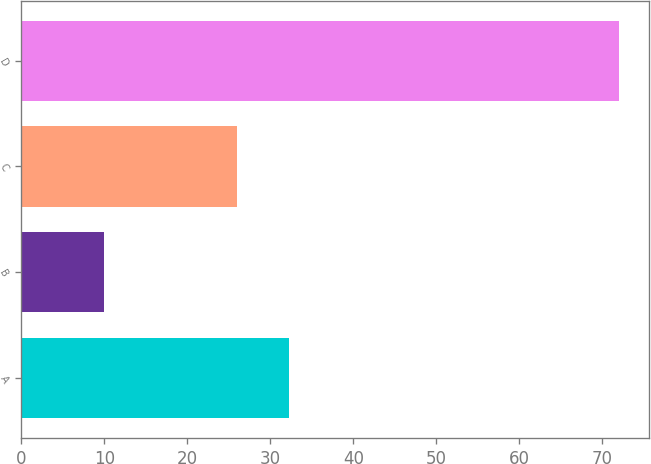Convert chart. <chart><loc_0><loc_0><loc_500><loc_500><bar_chart><fcel>A<fcel>B<fcel>C<fcel>D<nl><fcel>32.2<fcel>10<fcel>26<fcel>72<nl></chart> 